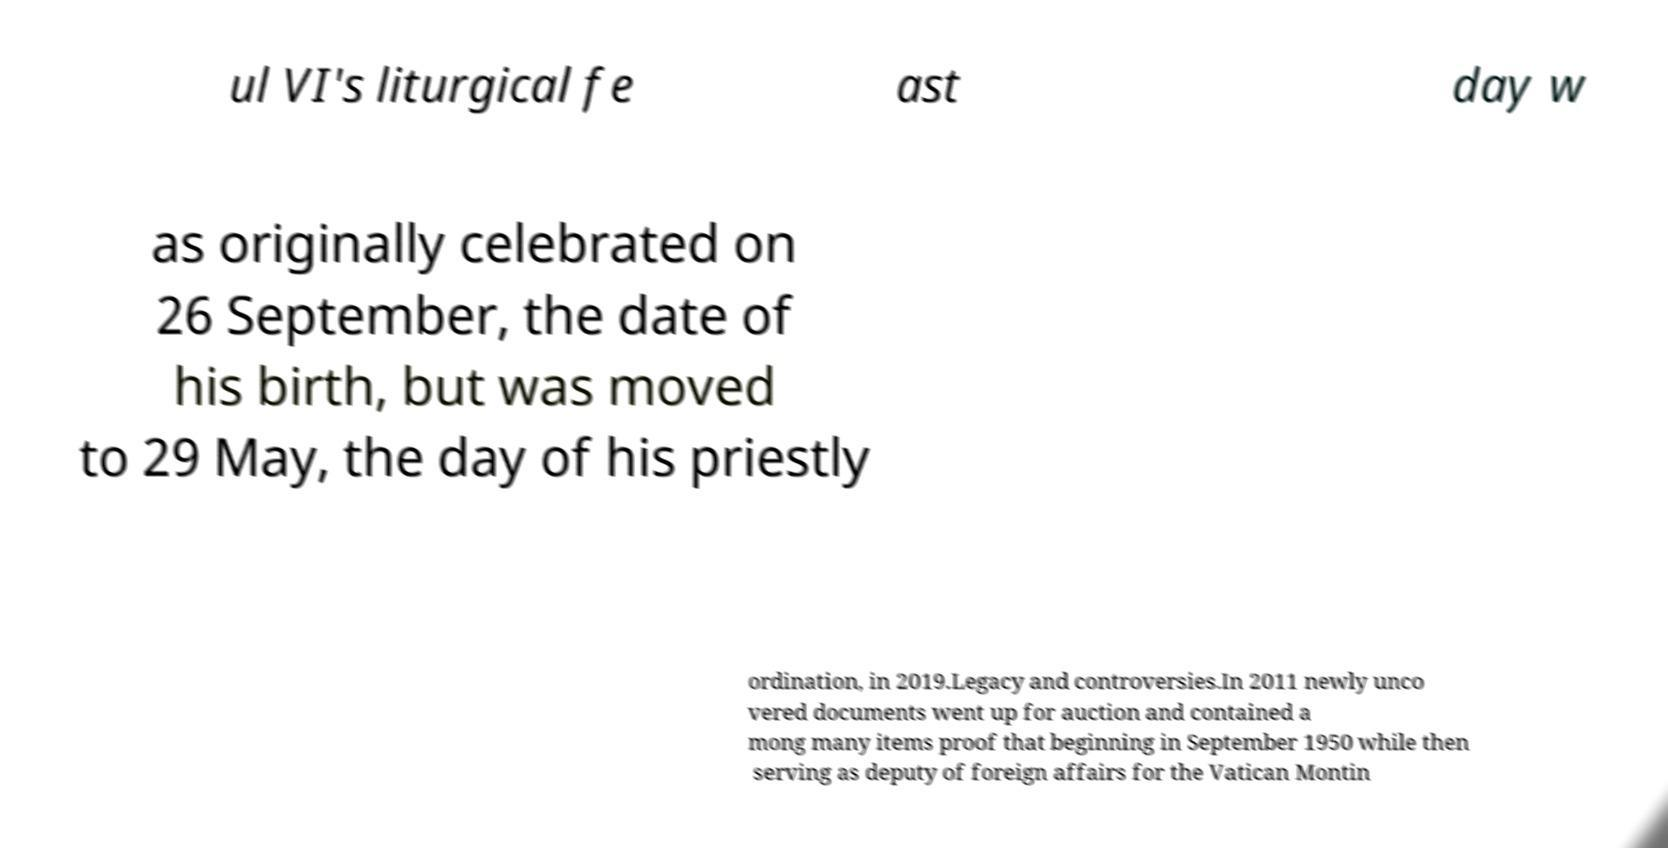Can you accurately transcribe the text from the provided image for me? ul VI's liturgical fe ast day w as originally celebrated on 26 September, the date of his birth, but was moved to 29 May, the day of his priestly ordination, in 2019.Legacy and controversies.In 2011 newly unco vered documents went up for auction and contained a mong many items proof that beginning in September 1950 while then serving as deputy of foreign affairs for the Vatican Montin 